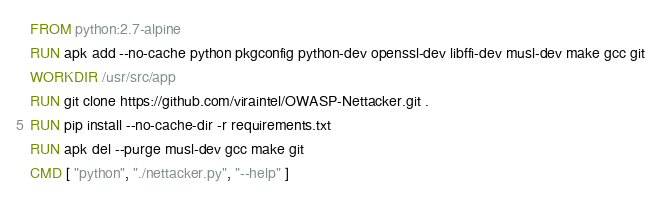Convert code to text. <code><loc_0><loc_0><loc_500><loc_500><_Dockerfile_>FROM python:2.7-alpine
RUN apk add --no-cache python pkgconfig python-dev openssl-dev libffi-dev musl-dev make gcc git
WORKDIR /usr/src/app
RUN git clone https://github.com/viraintel/OWASP-Nettacker.git .
RUN pip install --no-cache-dir -r requirements.txt
RUN apk del --purge musl-dev gcc make git
CMD [ "python", "./nettacker.py", "--help" ]</code> 